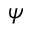Convert formula to latex. <formula><loc_0><loc_0><loc_500><loc_500>\psi</formula> 